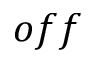<formula> <loc_0><loc_0><loc_500><loc_500>o f f</formula> 